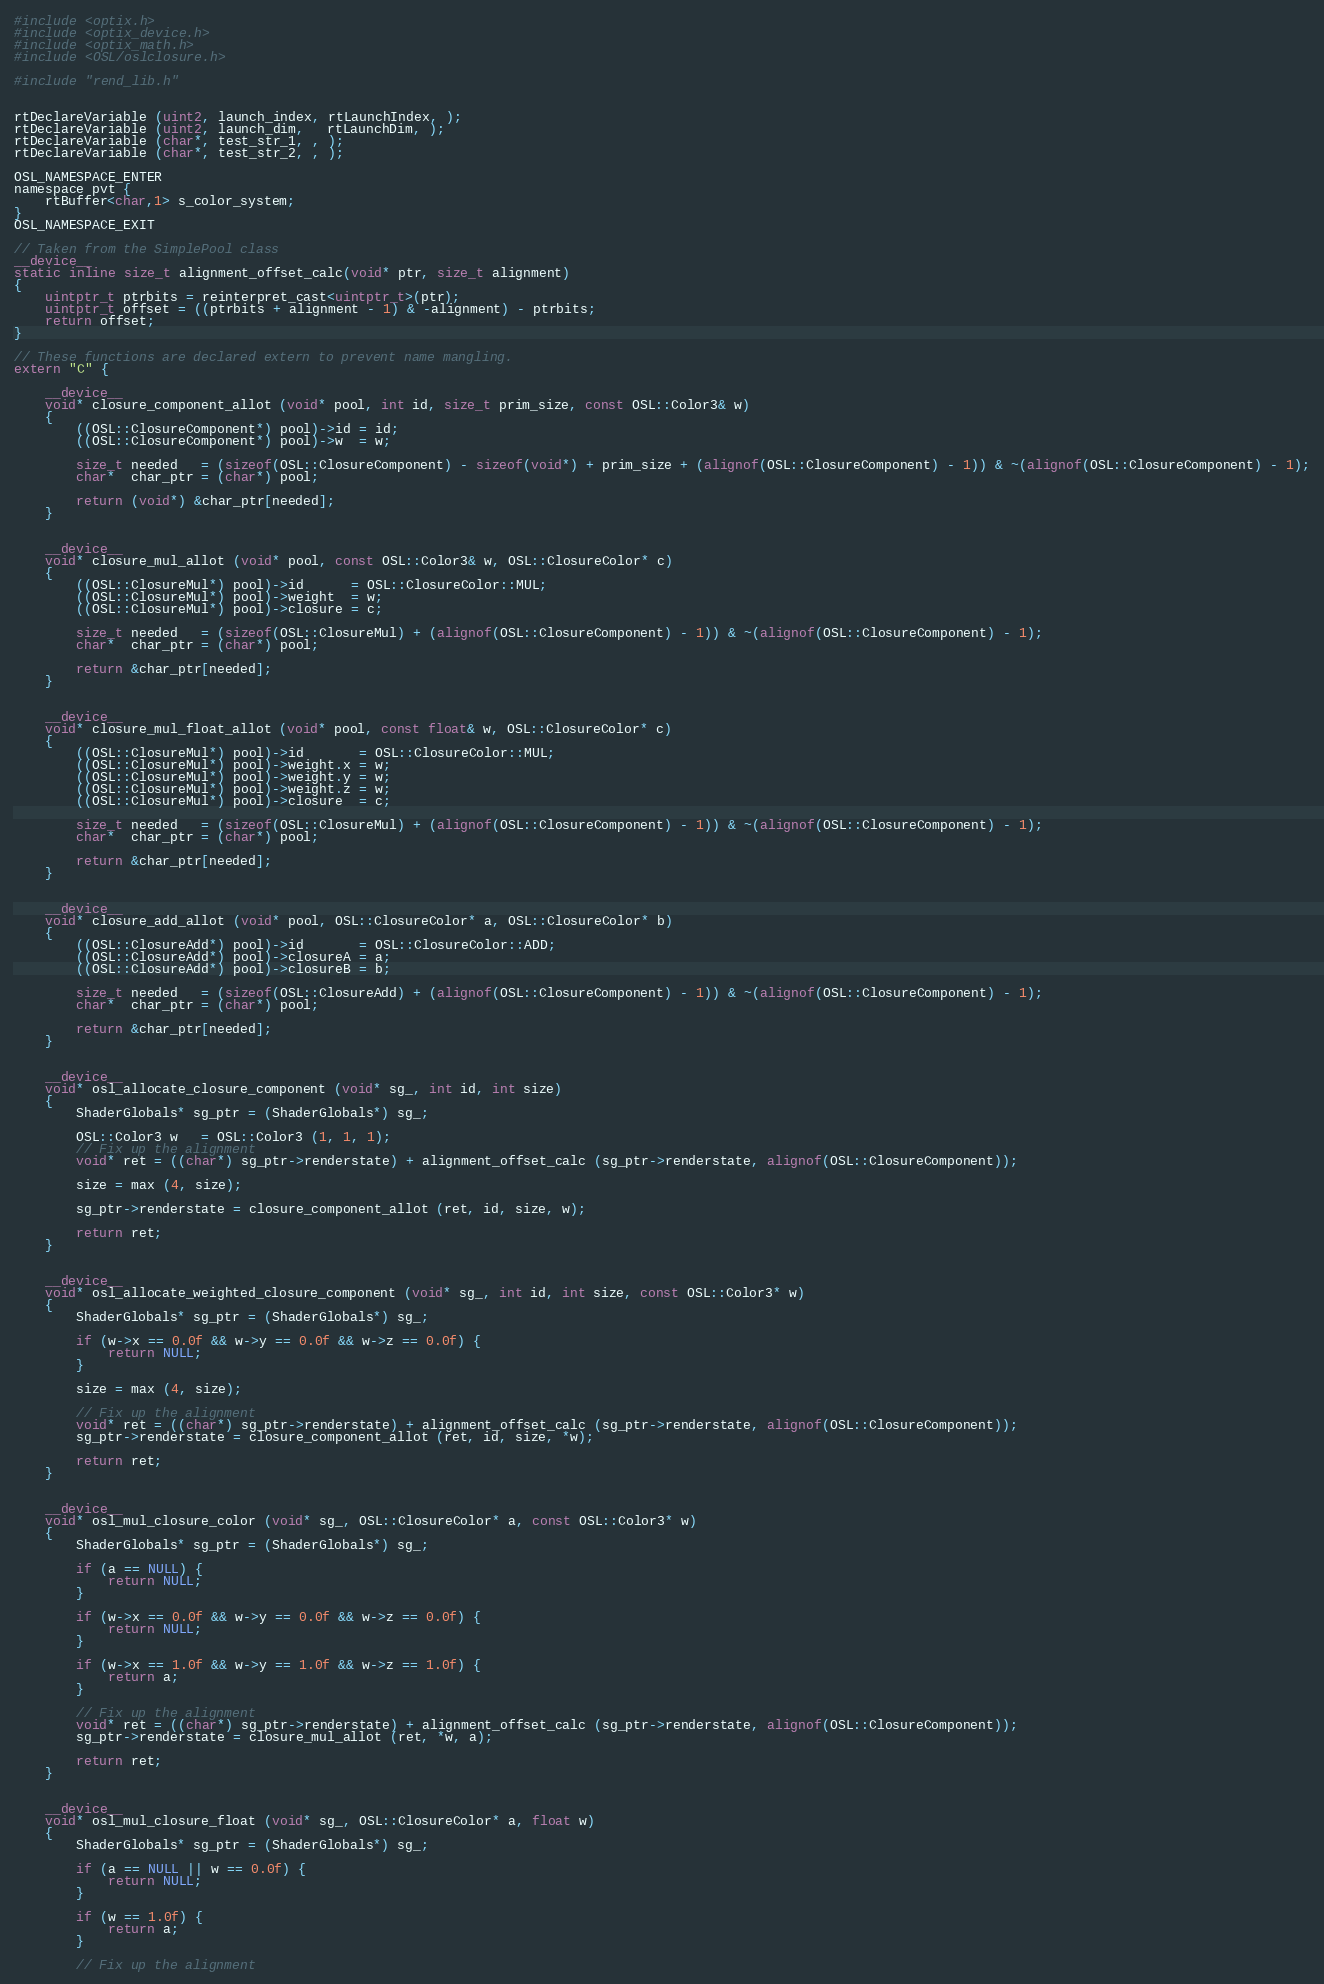<code> <loc_0><loc_0><loc_500><loc_500><_Cuda_>#include <optix.h>
#include <optix_device.h>
#include <optix_math.h>
#include <OSL/oslclosure.h>

#include "rend_lib.h"


rtDeclareVariable (uint2, launch_index, rtLaunchIndex, );
rtDeclareVariable (uint2, launch_dim,   rtLaunchDim, );
rtDeclareVariable (char*, test_str_1, , );
rtDeclareVariable (char*, test_str_2, , );

OSL_NAMESPACE_ENTER
namespace pvt {
    rtBuffer<char,1> s_color_system;
}
OSL_NAMESPACE_EXIT

// Taken from the SimplePool class
__device__
static inline size_t alignment_offset_calc(void* ptr, size_t alignment)
{
    uintptr_t ptrbits = reinterpret_cast<uintptr_t>(ptr);
    uintptr_t offset = ((ptrbits + alignment - 1) & -alignment) - ptrbits;
    return offset;
}

// These functions are declared extern to prevent name mangling.
extern "C" {

    __device__
    void* closure_component_allot (void* pool, int id, size_t prim_size, const OSL::Color3& w)
    {
        ((OSL::ClosureComponent*) pool)->id = id;
        ((OSL::ClosureComponent*) pool)->w  = w;

        size_t needed   = (sizeof(OSL::ClosureComponent) - sizeof(void*) + prim_size + (alignof(OSL::ClosureComponent) - 1)) & ~(alignof(OSL::ClosureComponent) - 1);
        char*  char_ptr = (char*) pool;

        return (void*) &char_ptr[needed];
    }


    __device__
    void* closure_mul_allot (void* pool, const OSL::Color3& w, OSL::ClosureColor* c)
    {
        ((OSL::ClosureMul*) pool)->id      = OSL::ClosureColor::MUL;
        ((OSL::ClosureMul*) pool)->weight  = w;
        ((OSL::ClosureMul*) pool)->closure = c;

        size_t needed   = (sizeof(OSL::ClosureMul) + (alignof(OSL::ClosureComponent) - 1)) & ~(alignof(OSL::ClosureComponent) - 1);
        char*  char_ptr = (char*) pool;

        return &char_ptr[needed];
    }


    __device__
    void* closure_mul_float_allot (void* pool, const float& w, OSL::ClosureColor* c)
    {
        ((OSL::ClosureMul*) pool)->id       = OSL::ClosureColor::MUL;
        ((OSL::ClosureMul*) pool)->weight.x = w;
        ((OSL::ClosureMul*) pool)->weight.y = w;
        ((OSL::ClosureMul*) pool)->weight.z = w;
        ((OSL::ClosureMul*) pool)->closure  = c;

        size_t needed   = (sizeof(OSL::ClosureMul) + (alignof(OSL::ClosureComponent) - 1)) & ~(alignof(OSL::ClosureComponent) - 1);
        char*  char_ptr = (char*) pool;

        return &char_ptr[needed];
    }


    __device__
    void* closure_add_allot (void* pool, OSL::ClosureColor* a, OSL::ClosureColor* b)
    {
        ((OSL::ClosureAdd*) pool)->id       = OSL::ClosureColor::ADD;
        ((OSL::ClosureAdd*) pool)->closureA = a;
        ((OSL::ClosureAdd*) pool)->closureB = b;

        size_t needed   = (sizeof(OSL::ClosureAdd) + (alignof(OSL::ClosureComponent) - 1)) & ~(alignof(OSL::ClosureComponent) - 1);
        char*  char_ptr = (char*) pool;

        return &char_ptr[needed];
    }


    __device__
    void* osl_allocate_closure_component (void* sg_, int id, int size)
    {
        ShaderGlobals* sg_ptr = (ShaderGlobals*) sg_;

        OSL::Color3 w   = OSL::Color3 (1, 1, 1);
        // Fix up the alignment
        void* ret = ((char*) sg_ptr->renderstate) + alignment_offset_calc (sg_ptr->renderstate, alignof(OSL::ClosureComponent));

        size = max (4, size);

        sg_ptr->renderstate = closure_component_allot (ret, id, size, w);

        return ret;
    }


    __device__
    void* osl_allocate_weighted_closure_component (void* sg_, int id, int size, const OSL::Color3* w)
    {
        ShaderGlobals* sg_ptr = (ShaderGlobals*) sg_;

        if (w->x == 0.0f && w->y == 0.0f && w->z == 0.0f) {
            return NULL;
        }

        size = max (4, size);

        // Fix up the alignment
        void* ret = ((char*) sg_ptr->renderstate) + alignment_offset_calc (sg_ptr->renderstate, alignof(OSL::ClosureComponent));
        sg_ptr->renderstate = closure_component_allot (ret, id, size, *w);

        return ret;
    }


    __device__
    void* osl_mul_closure_color (void* sg_, OSL::ClosureColor* a, const OSL::Color3* w)
    {
        ShaderGlobals* sg_ptr = (ShaderGlobals*) sg_;

        if (a == NULL) {
            return NULL;
        }

        if (w->x == 0.0f && w->y == 0.0f && w->z == 0.0f) {
            return NULL;
        }

        if (w->x == 1.0f && w->y == 1.0f && w->z == 1.0f) {
            return a;
        }

        // Fix up the alignment
        void* ret = ((char*) sg_ptr->renderstate) + alignment_offset_calc (sg_ptr->renderstate, alignof(OSL::ClosureComponent));
        sg_ptr->renderstate = closure_mul_allot (ret, *w, a);

        return ret;
    }


    __device__
    void* osl_mul_closure_float (void* sg_, OSL::ClosureColor* a, float w)
    {
        ShaderGlobals* sg_ptr = (ShaderGlobals*) sg_;

        if (a == NULL || w == 0.0f) {
            return NULL;
        }

        if (w == 1.0f) {
            return a;
        }

        // Fix up the alignment</code> 